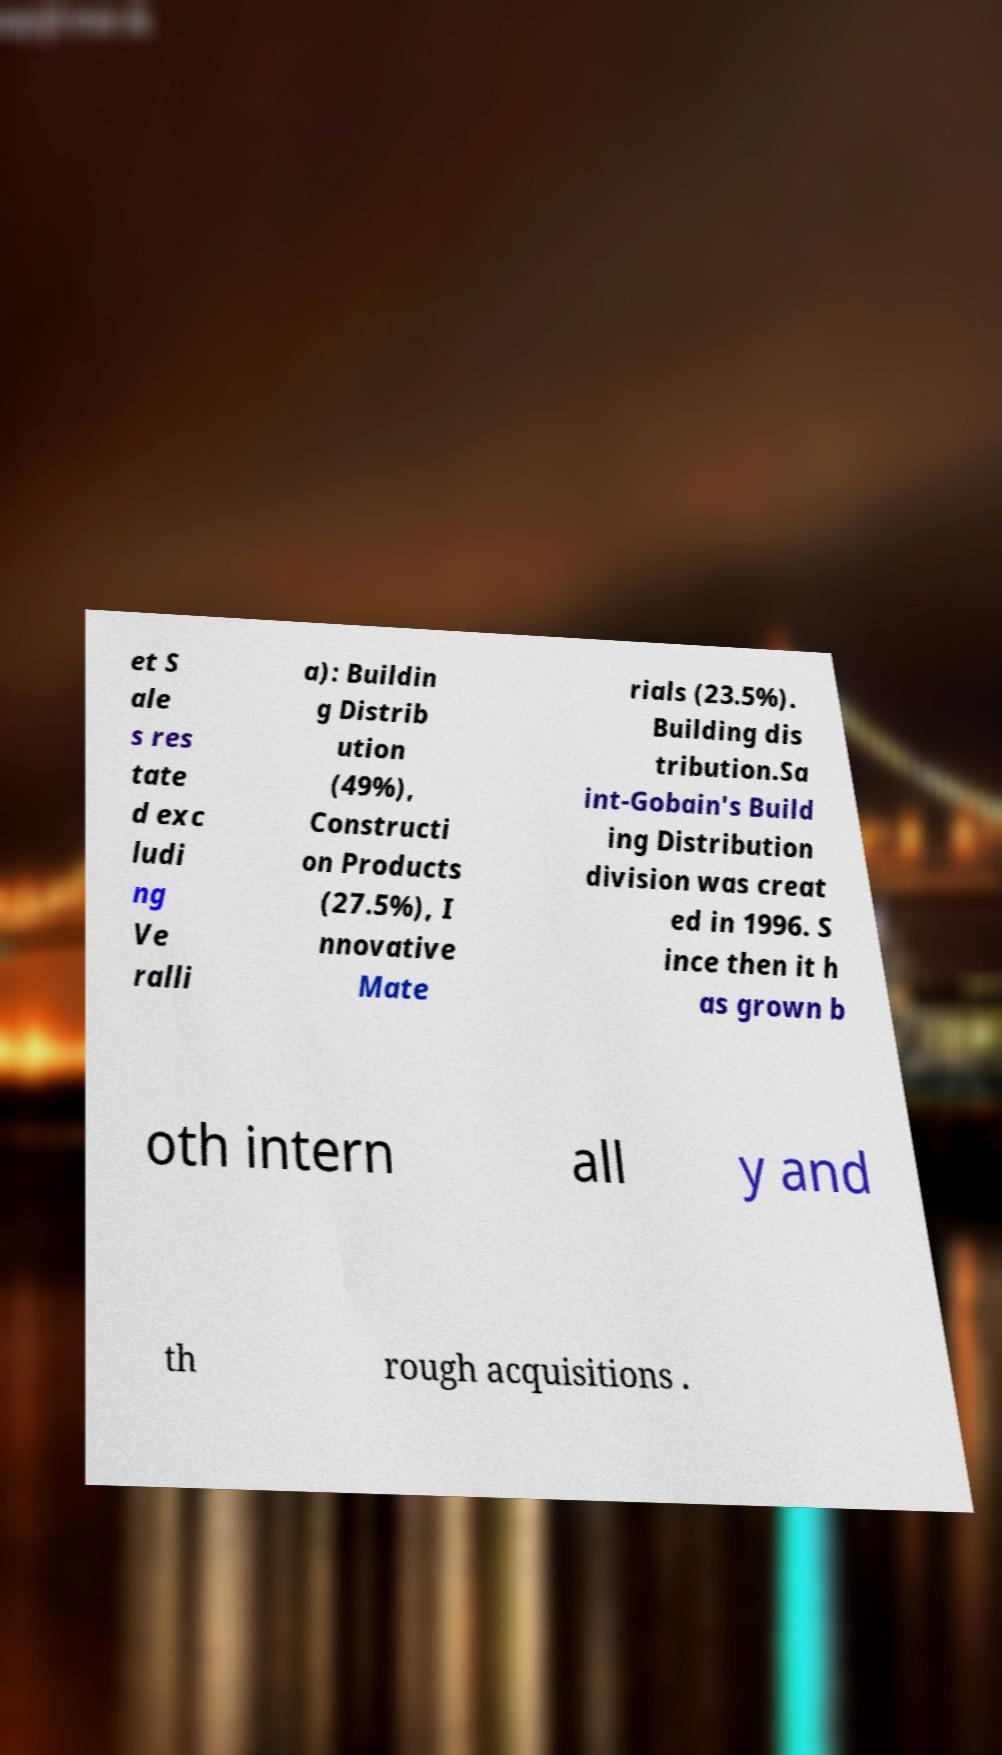Can you accurately transcribe the text from the provided image for me? et S ale s res tate d exc ludi ng Ve ralli a): Buildin g Distrib ution (49%), Constructi on Products (27.5%), I nnovative Mate rials (23.5%). Building dis tribution.Sa int-Gobain's Build ing Distribution division was creat ed in 1996. S ince then it h as grown b oth intern all y and th rough acquisitions . 